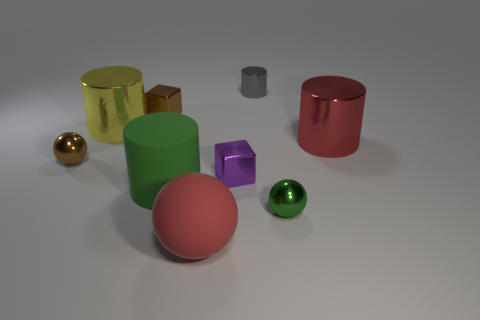There is a yellow object; does it have the same shape as the tiny object in front of the large green matte cylinder?
Offer a very short reply. No. What is the material of the ball that is the same size as the yellow metallic cylinder?
Your response must be concise. Rubber. Is there a small metal thing of the same color as the large matte cylinder?
Provide a short and direct response. Yes. What shape is the tiny thing that is both behind the yellow shiny cylinder and to the left of the big red rubber ball?
Your response must be concise. Cube. What number of big red objects are the same material as the big green cylinder?
Provide a succinct answer. 1. Is the number of big rubber cylinders that are to the right of the tiny shiny cylinder less than the number of red shiny cylinders that are behind the large green rubber thing?
Give a very brief answer. Yes. What is the green cylinder that is in front of the cylinder that is on the left side of the metal cube on the left side of the big red matte sphere made of?
Give a very brief answer. Rubber. There is a cylinder that is both in front of the gray object and on the right side of the red matte thing; how big is it?
Your response must be concise. Large. What number of cubes are either small objects or big yellow objects?
Provide a short and direct response. 2. The other rubber cylinder that is the same size as the yellow cylinder is what color?
Your response must be concise. Green. 